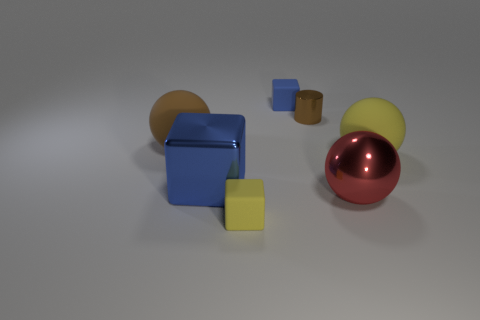How many blue blocks must be subtracted to get 1 blue blocks? 1 Subtract all large yellow spheres. How many spheres are left? 2 Add 1 yellow blocks. How many objects exist? 8 Subtract all blue blocks. How many blocks are left? 1 Subtract 3 cubes. How many cubes are left? 0 Subtract all cyan cylinders. Subtract all matte cubes. How many objects are left? 5 Add 3 small yellow matte cubes. How many small yellow matte cubes are left? 4 Add 7 tiny rubber cubes. How many tiny rubber cubes exist? 9 Subtract 0 brown cubes. How many objects are left? 7 Subtract all spheres. How many objects are left? 4 